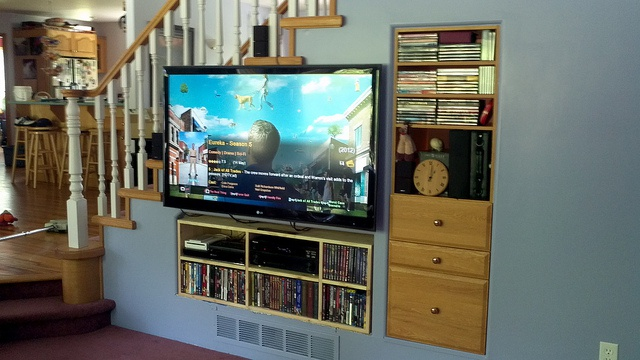Describe the objects in this image and their specific colors. I can see book in olive, black, darkgray, and gray tones, tv in olive, black, lightblue, ivory, and gray tones, people in olive, black, gray, navy, and darkgray tones, clock in olive, black, and maroon tones, and chair in olive, maroon, and black tones in this image. 